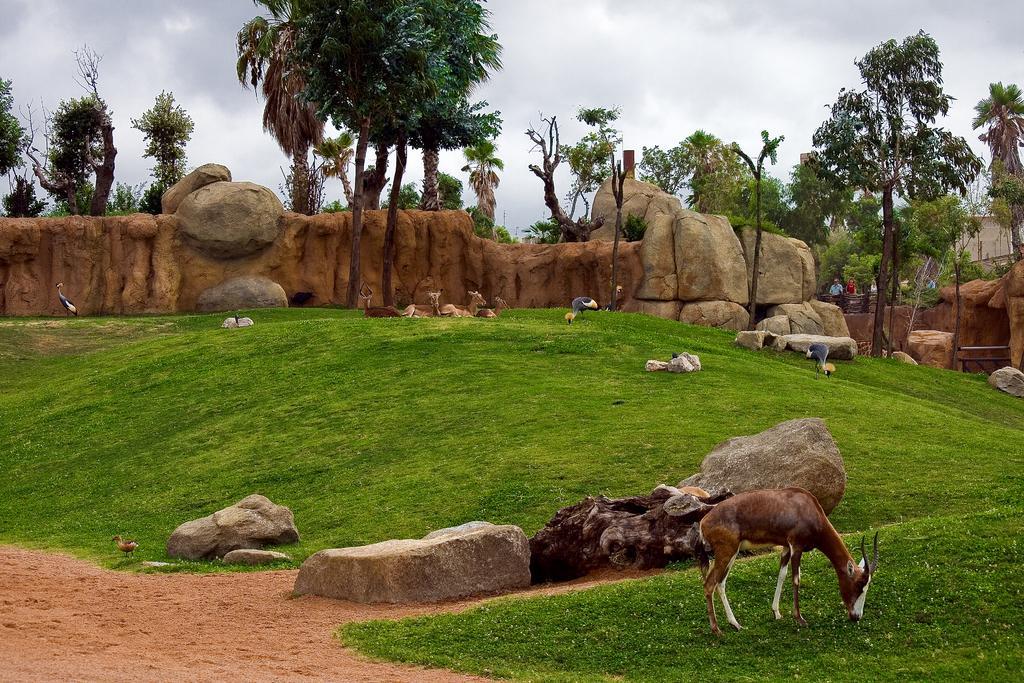Can you describe this image briefly? In this image we can see animals and birds standing and lying on the ground, stones, rocks, trees, persons walking and sky with clouds. 